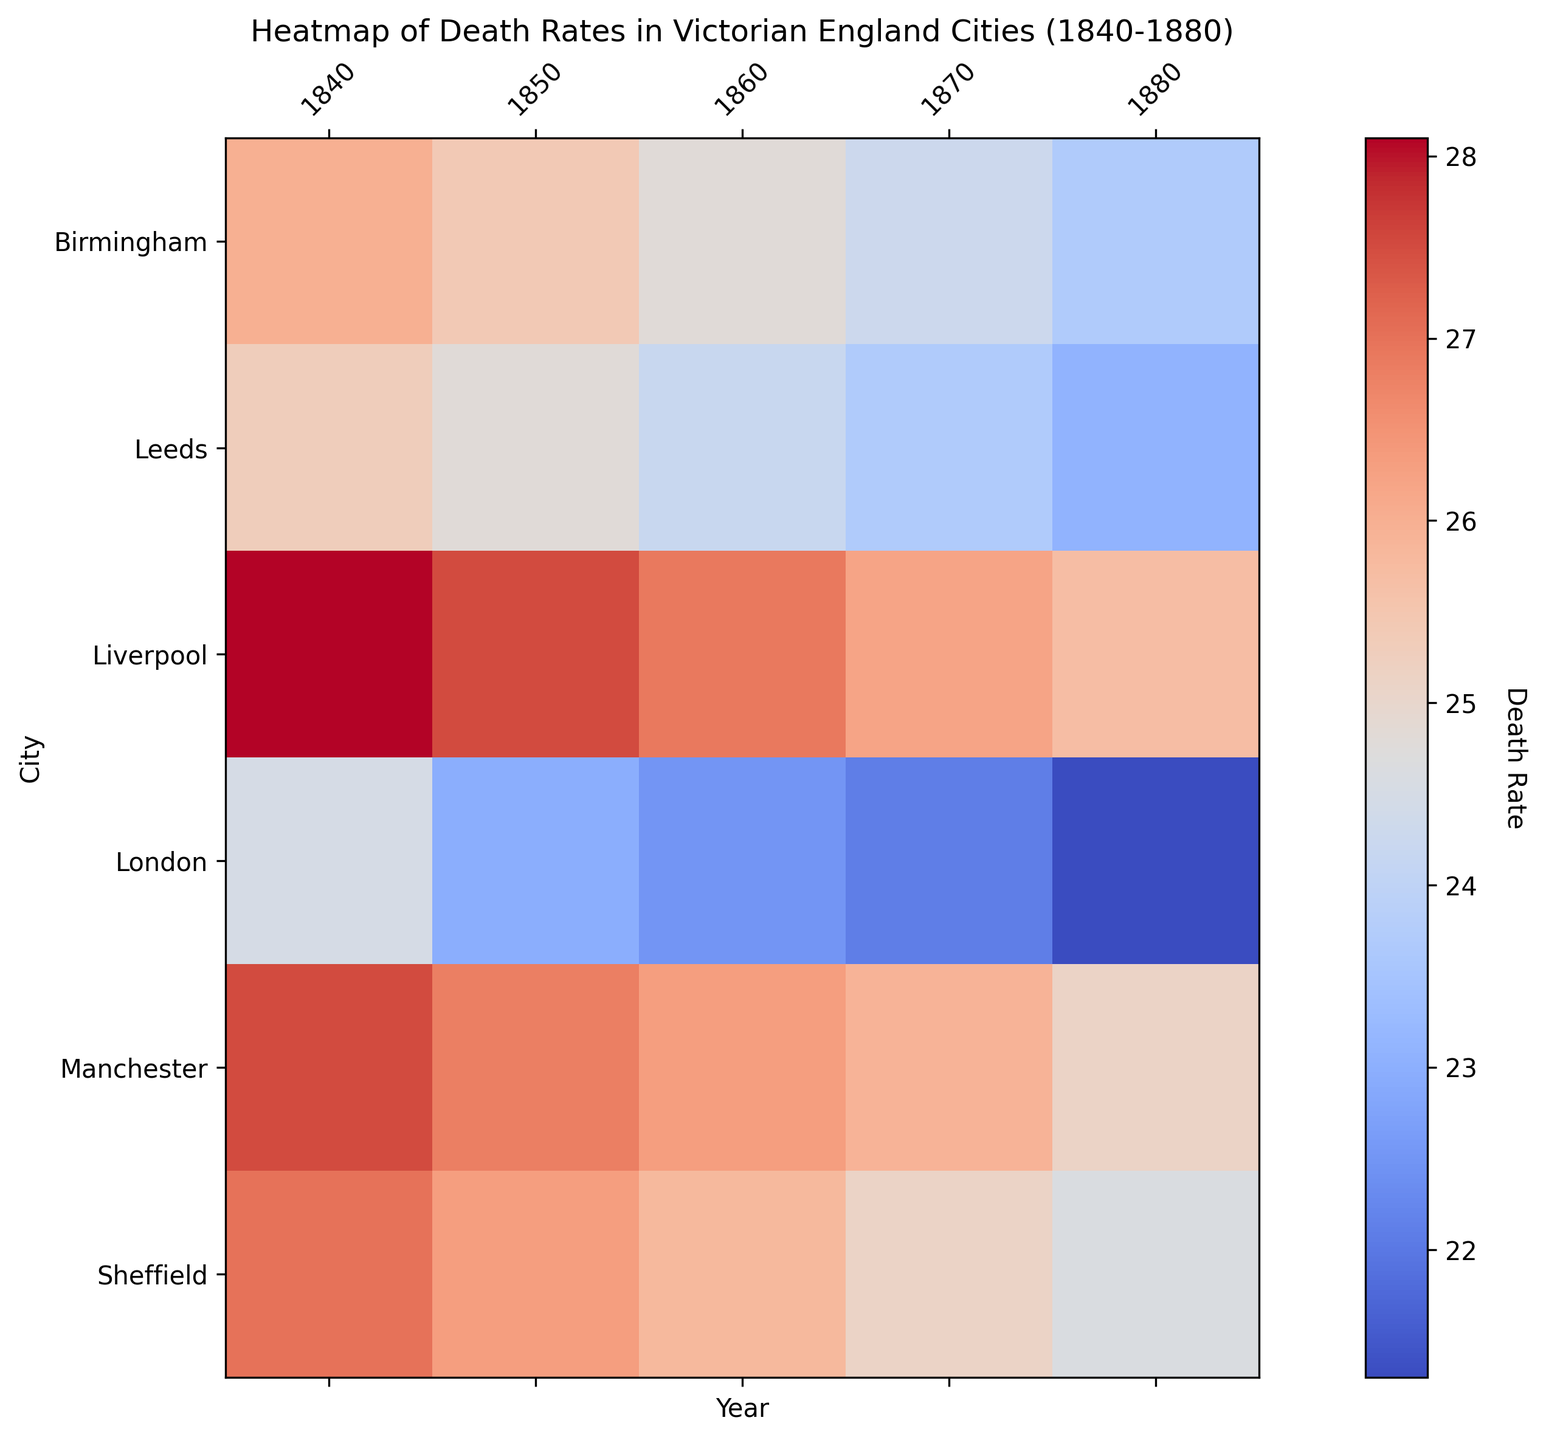What trend can you observe in death rates in London from 1840 to 1880? Each cell representing London from 1840 to 1880 progressively shows a cooler color, indicating lower death rates over time. Hence, the death rates in London decrease as time progresses.
Answer: Decreasing trend Which city had the highest death rate in 1840? By comparing the color intensities of the cells corresponding to the different cities in 1840, the cell for Liverpool is the darkest, indicating the highest death rate.
Answer: Liverpool Between 1840 and 1880, which city experienced the most significant decrease in death rate? To find this, compare the color change for each city from 1840 to 1880. The largest shift toward cooler colors (indicating the greatest reduction) is seen in Liverpool.
Answer: Liverpool Is there a correlation between urbanization rate and death rate across the cities presented over the years? By observing the general color shifts and aligning them with the years, there's a visible trend showing cities with higher urbanization rates (like London) tend to have lower death rates over time compared to those with slower urbanization (like Liverpool).
Answer: Yes Which city maintained the lowest death rate consistently over the years? By scanning across the rows for each city from 1840 to 1880, Sheffield generally has lighter shades compared to other cities, indicating consistently lower death rates.
Answer: Sheffield 